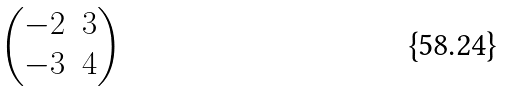<formula> <loc_0><loc_0><loc_500><loc_500>\begin{pmatrix} - 2 & 3 \\ - 3 & 4 \end{pmatrix}</formula> 